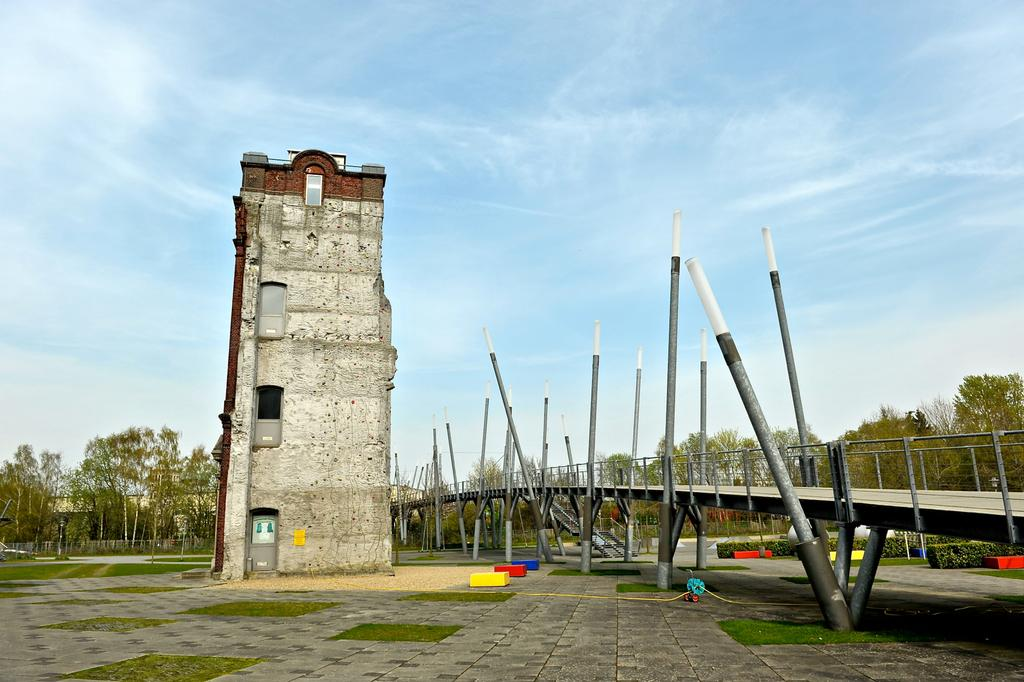What is the main structure in the image? There is a tower in the image. What is located beside the tower? There is a bridge beside the tower. What can be seen in the background of the image? There are trees and buildings in the background of the image. What type of discussion is taking place near the tower in the image? There is no discussion taking place near the tower in the image. Can you see any airplanes or signs of an airport in the image? There is no mention of an airport or airplanes in the image. 